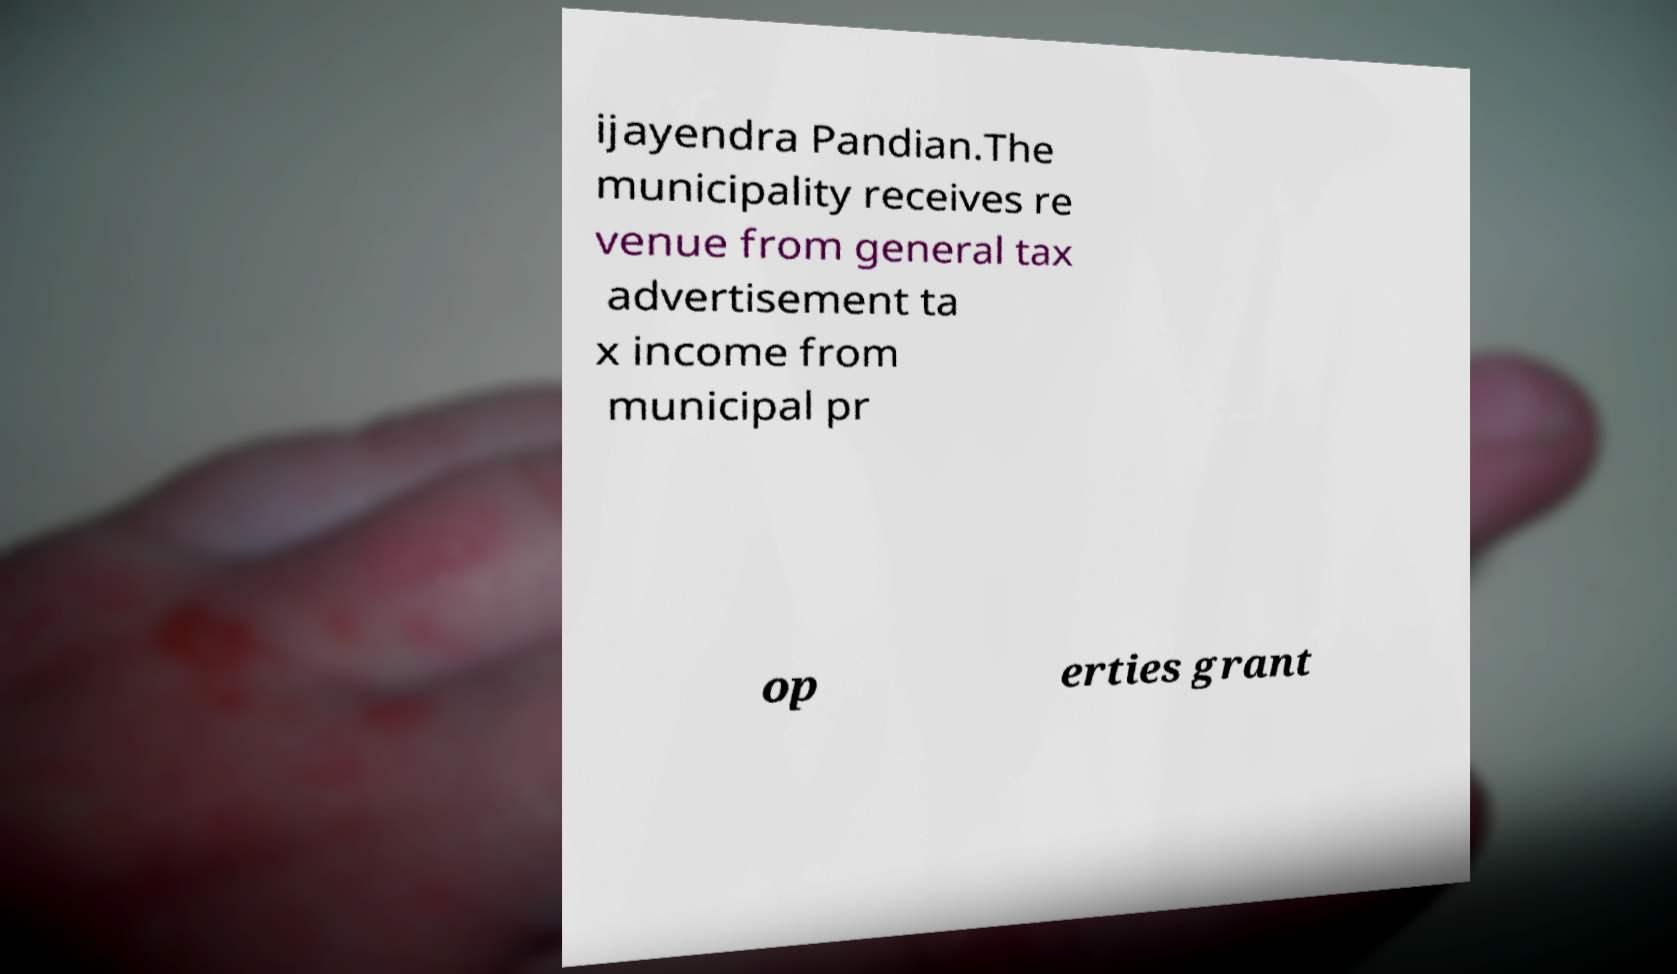Please read and relay the text visible in this image. What does it say? ijayendra Pandian.The municipality receives re venue from general tax advertisement ta x income from municipal pr op erties grant 